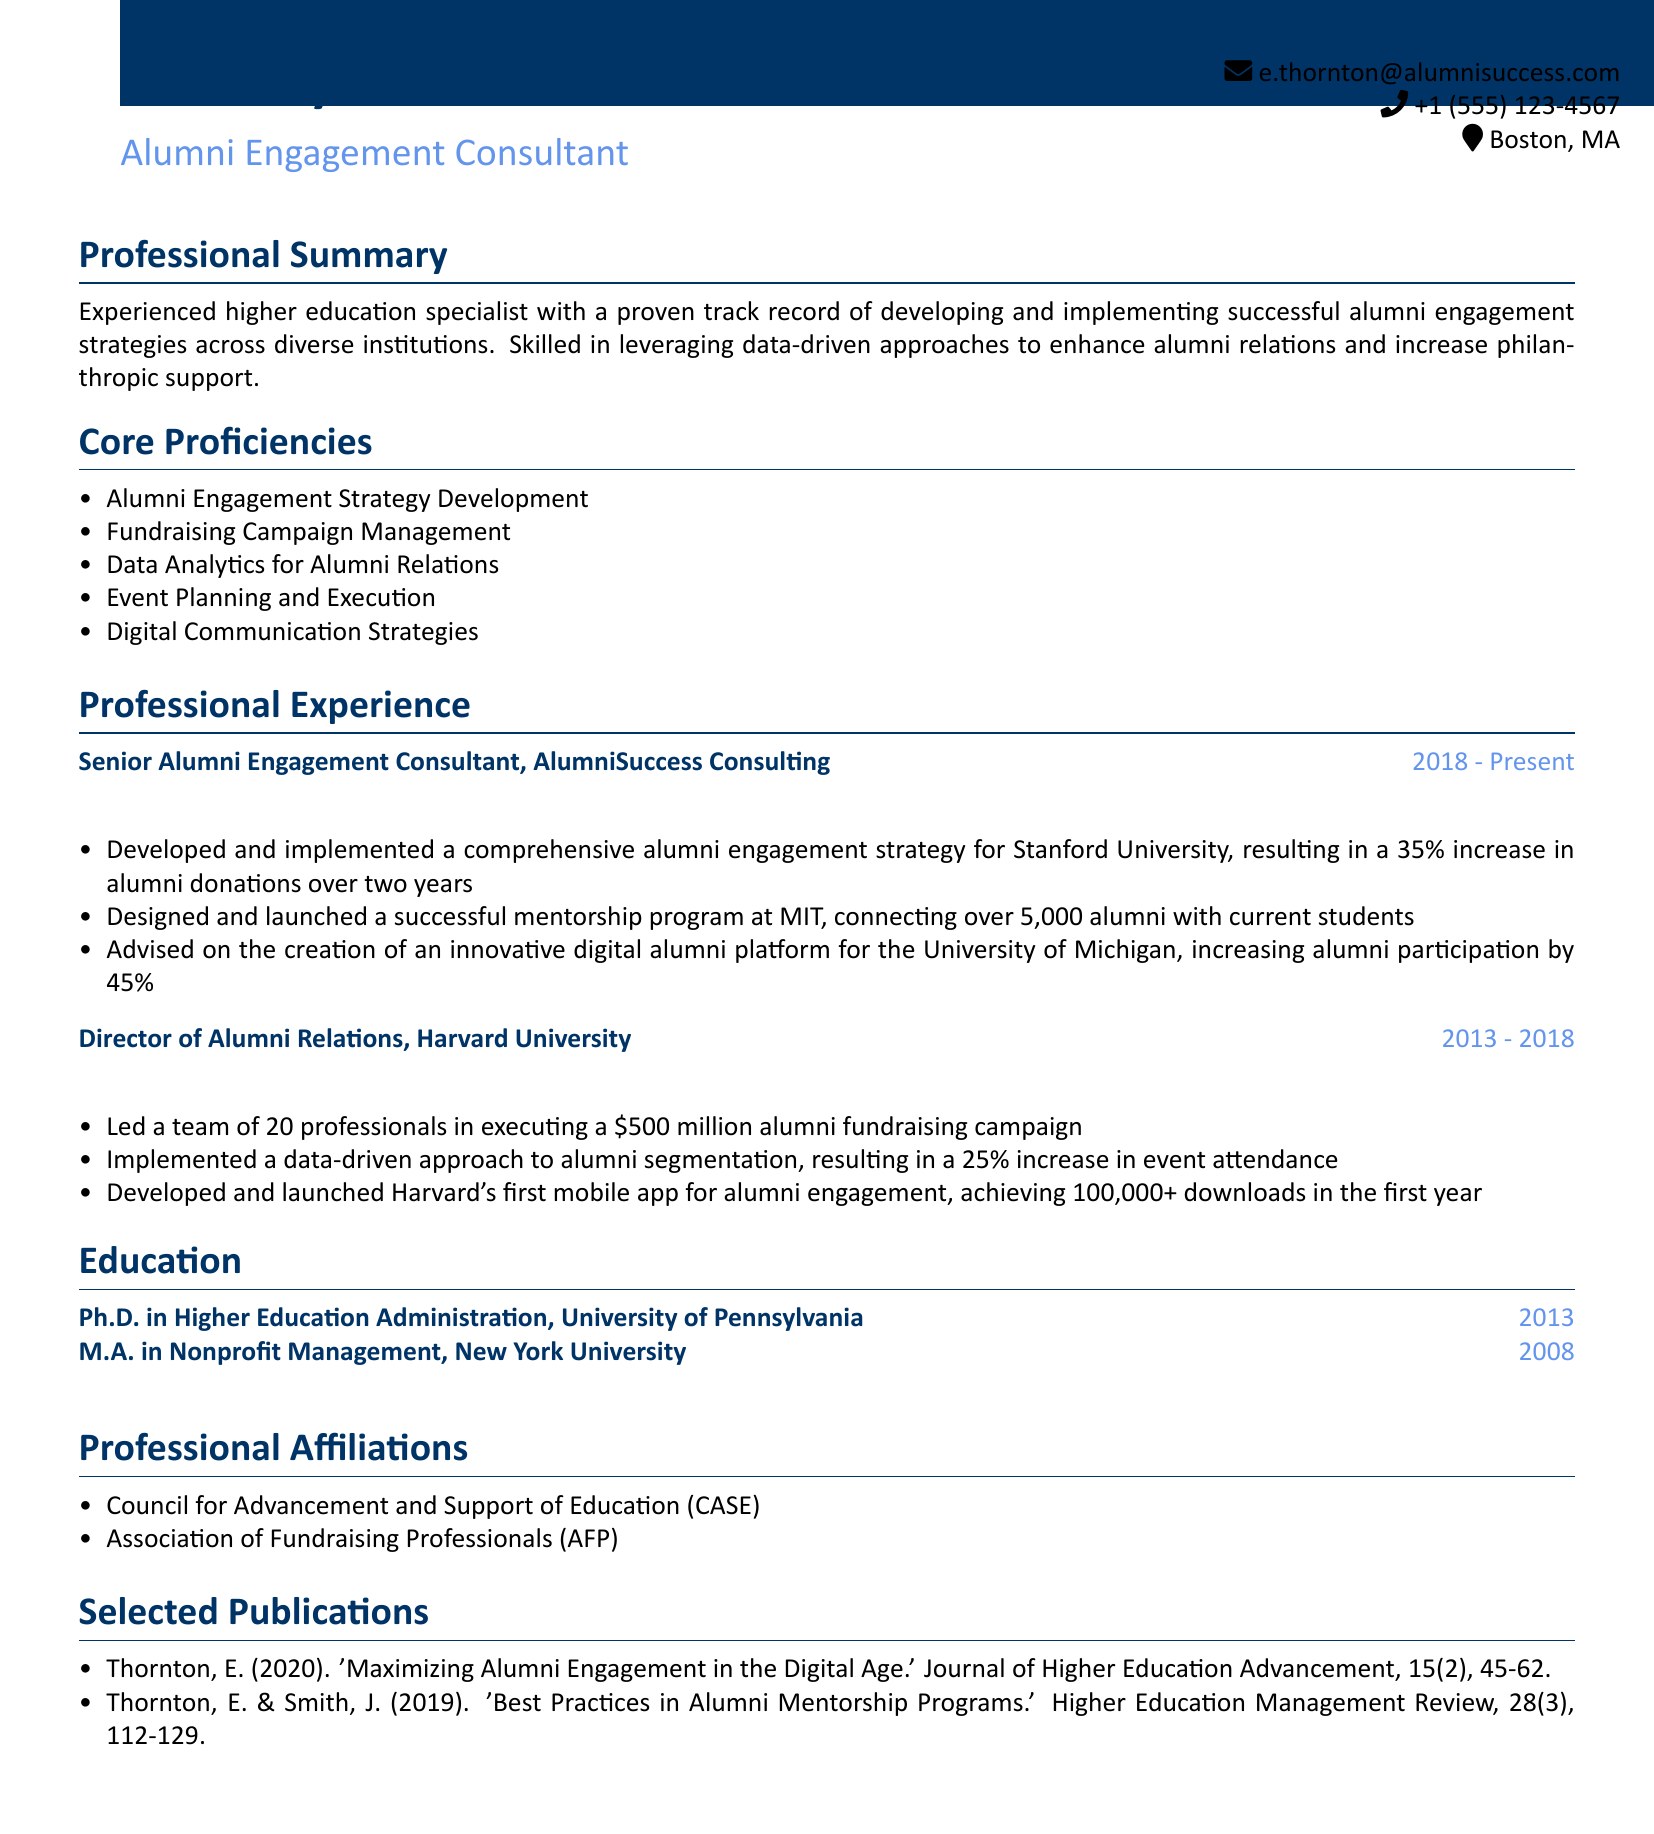What is the name of the consultant? The consultant's name is listed at the top of the document as Dr. Emily Thornton.
Answer: Dr. Emily Thornton What is the title of the document's author? The title is indicated right below the name, referring to the author's professional position.
Answer: Alumni Engagement Consultant What organization is associated with the most recent position held? The most recent position and organization are specified in the professional experience section of the document.
Answer: AlumniSuccess Consulting How many years did Dr. Thornton work at Harvard University? The duration of the employment at Harvard is provided in the professional experience section.
Answer: 5 years What percentage increase in alumni donations did the strategy for Stanford University achieve? The achievement details for Stanford University are included in the professional experience section.
Answer: 35% What is the total number of alumni connected through the MIT mentorship program? The number of alumni connected through the program is stated in the professional experience section.
Answer: 5,000 What type of degree did Dr. Thornton earn from the University of Pennsylvania? The education section specifies the degree obtained from the University of Pennsylvania.
Answer: Ph.D. in Higher Education Administration Which professional organization is mentioned in the affiliations section? The professional affiliations are listed in a section of the document that outlines Dr. Thornton's memberships.
Answer: Council for Advancement and Support of Education (CASE) What is the publication year of Dr. Thornton's article on maximizing alumni engagement? The publication details in the selected publications section give the year of the article.
Answer: 2020 